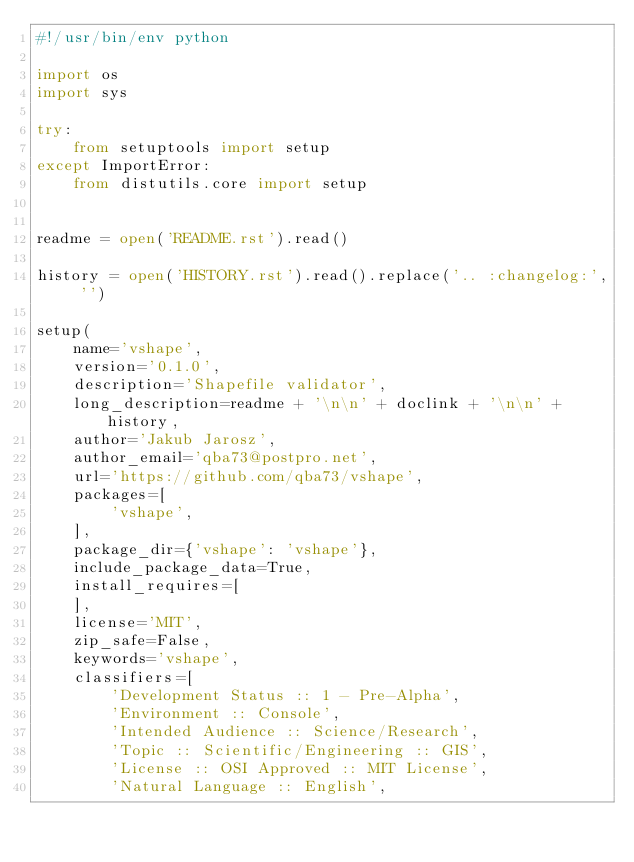<code> <loc_0><loc_0><loc_500><loc_500><_Python_>#!/usr/bin/env python

import os
import sys

try:
    from setuptools import setup
except ImportError:
    from distutils.core import setup


readme = open('README.rst').read()

history = open('HISTORY.rst').read().replace('.. :changelog:', '')

setup(
    name='vshape',
    version='0.1.0',
    description='Shapefile validator',
    long_description=readme + '\n\n' + doclink + '\n\n' + history,
    author='Jakub Jarosz',
    author_email='qba73@postpro.net',
    url='https://github.com/qba73/vshape',
    packages=[
        'vshape',
    ],
    package_dir={'vshape': 'vshape'},
    include_package_data=True,
    install_requires=[
    ],
    license='MIT',
    zip_safe=False,
    keywords='vshape',
    classifiers=[
        'Development Status :: 1 - Pre-Alpha',
        'Environment :: Console',
        'Intended Audience :: Science/Research',
        'Topic :: Scientific/Engineering :: GIS',
        'License :: OSI Approved :: MIT License',
        'Natural Language :: English',</code> 